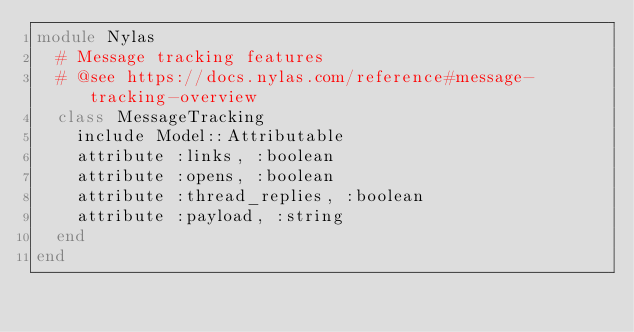<code> <loc_0><loc_0><loc_500><loc_500><_Ruby_>module Nylas
  # Message tracking features
  # @see https://docs.nylas.com/reference#message-tracking-overview
  class MessageTracking
    include Model::Attributable
    attribute :links, :boolean
    attribute :opens, :boolean
    attribute :thread_replies, :boolean
    attribute :payload, :string
  end
end
</code> 